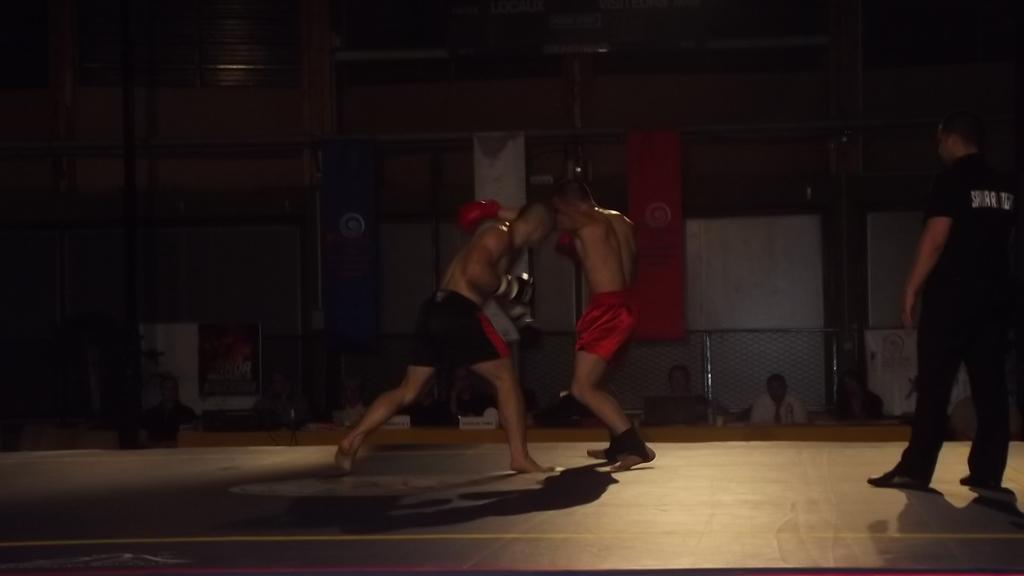What are the 2 people in the image doing? The 2 people in the image are wrestling. Can you describe the person standing on the right side of the image? The person standing on the right side of the image is wearing a black dress. What can be seen in the background of the image? There are other people sitting in the background of the image, and 2 flags are hanging there as well. What type of disease is the person in the black dress suffering from in the image? There is no indication in the image that the person in the black dress is suffering from any disease. Can you hear the person coughing in the image? The image is silent, so it is not possible to hear any sounds, including coughing. 